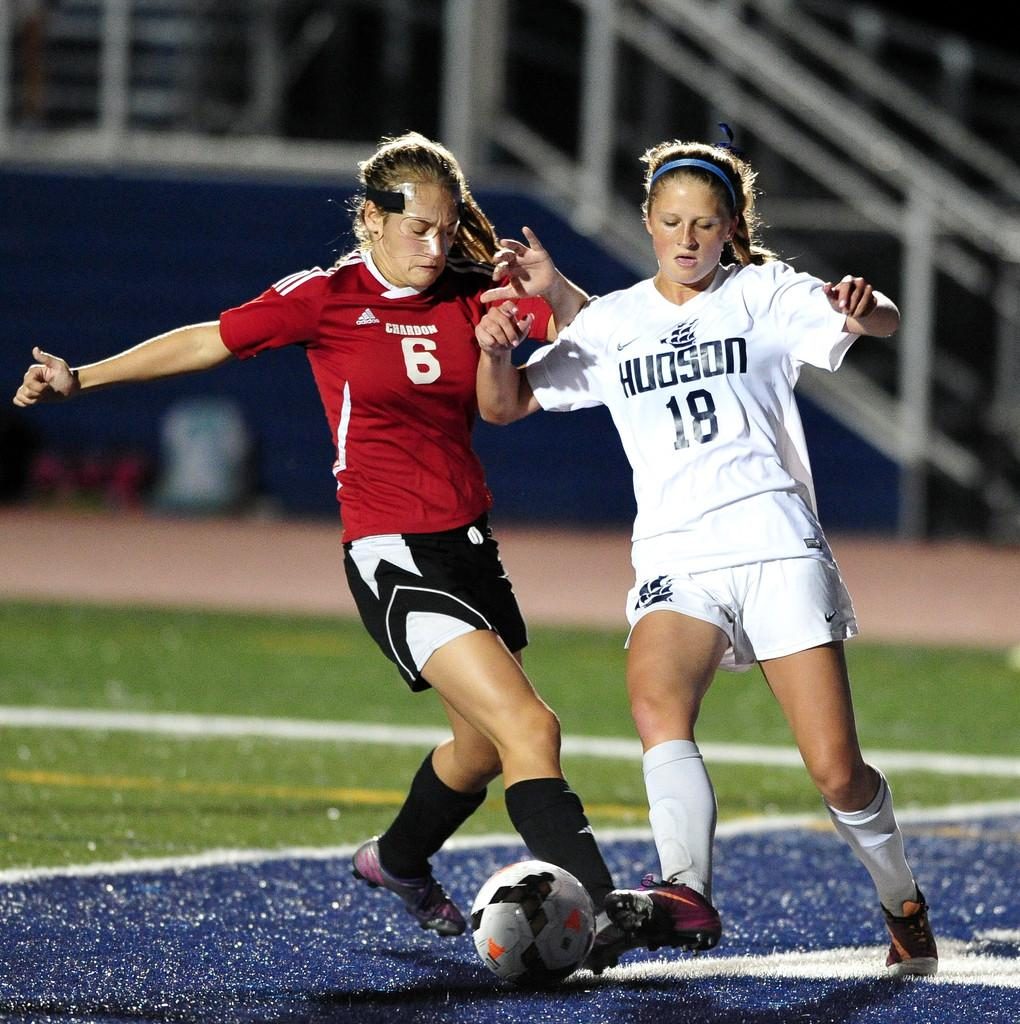How many people are in the image? There are two persons in the image. What are the two persons doing in the image? The two persons are playing football. What is the surface they are playing on? The ground is grassy. What can be seen in the background of the image? There is a wall in the image. What type of tomatoes are being used as footballs in the image? There are no tomatoes present in the image, and the footballs are not made of tomatoes. 